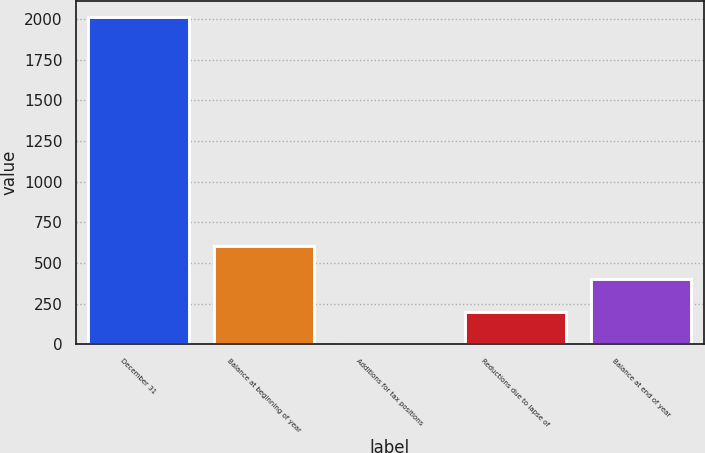<chart> <loc_0><loc_0><loc_500><loc_500><bar_chart><fcel>December 31<fcel>Balance at beginning of year<fcel>Additions for tax positions<fcel>Reductions due to lapse of<fcel>Balance at end of year<nl><fcel>2013<fcel>604.6<fcel>1<fcel>202.2<fcel>403.4<nl></chart> 